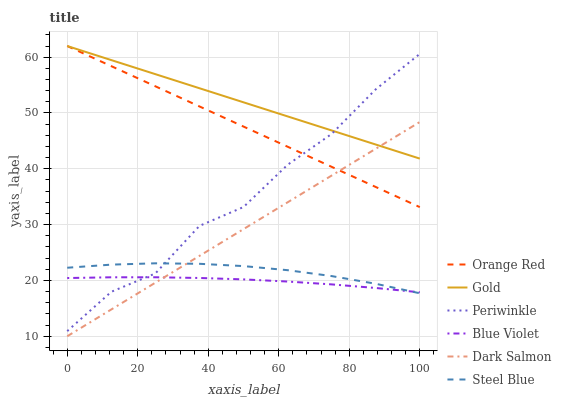Does Blue Violet have the minimum area under the curve?
Answer yes or no. Yes. Does Gold have the maximum area under the curve?
Answer yes or no. Yes. Does Steel Blue have the minimum area under the curve?
Answer yes or no. No. Does Steel Blue have the maximum area under the curve?
Answer yes or no. No. Is Orange Red the smoothest?
Answer yes or no. Yes. Is Periwinkle the roughest?
Answer yes or no. Yes. Is Steel Blue the smoothest?
Answer yes or no. No. Is Steel Blue the roughest?
Answer yes or no. No. Does Dark Salmon have the lowest value?
Answer yes or no. Yes. Does Steel Blue have the lowest value?
Answer yes or no. No. Does Orange Red have the highest value?
Answer yes or no. Yes. Does Steel Blue have the highest value?
Answer yes or no. No. Is Steel Blue less than Orange Red?
Answer yes or no. Yes. Is Gold greater than Steel Blue?
Answer yes or no. Yes. Does Dark Salmon intersect Gold?
Answer yes or no. Yes. Is Dark Salmon less than Gold?
Answer yes or no. No. Is Dark Salmon greater than Gold?
Answer yes or no. No. Does Steel Blue intersect Orange Red?
Answer yes or no. No. 